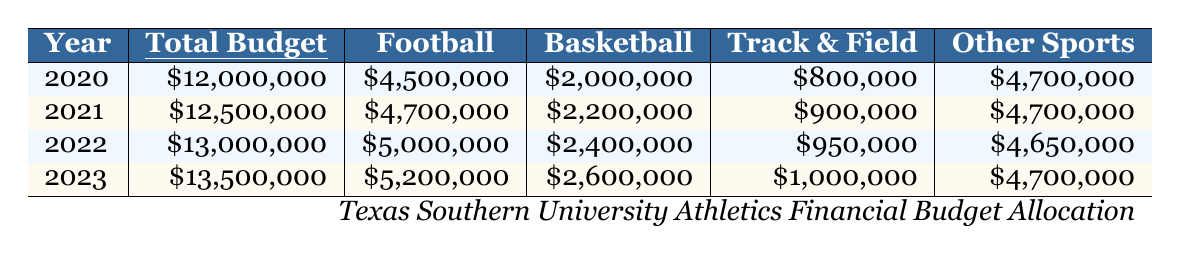What was the total budget for Texas Southern University Athletics in 2022? Referring to the 2022 row in the table, the total budget is listed as $13,000,000.
Answer: $13,000,000 How much did Texas Southern University allocate for football in 2023? The table shows that the football budget for 2023 is $5,200,000.
Answer: $5,200,000 Which year had the highest allocation for basketball? By comparing the basketball budgets in each year, 2023 has the highest allocation at $2,600,000.
Answer: 2023 What is the average budget for track and field over these four years? Adding the track and field budgets: ($800,000 + $900,000 + $950,000 + $1,000,000 = $3,650,000) and dividing by 4 gives an average of $912,500.
Answer: $912,500 Did the total budget increase every year from 2020 to 2023? The total budgets for each year are: $12,000,000 (2020), $12,500,000 (2021), $13,000,000 (2022), and $13,500,000 (2023), which shows an increase each year.
Answer: Yes What was the difference in football budget allocation between 2020 and 2023? The football budget for 2020 was $4,500,000 and for 2023 it was $5,200,000. The difference is $5,200,000 - $4,500,000 = $700,000.
Answer: $700,000 What percentage of the total budget in 2021 was allocated to other sports? In 2021, the total budget was $12,500,000, and the allocation for other sports was $4,700,000. The percentage is ($4,700,000 / $12,500,000) * 100 = 37.6%.
Answer: 37.6% Which sport had a consistent budget allocation over these years? The budget for other sports remained the same at $4,700,000 in both 2020 and 2021, and then adjusted slightly down to $4,650,000 in 2022 and went back to $4,700,000 in 2023, indicating inconsistency but relative stability.
Answer: Inconsistent, but relatively stable What was the total combined budget for football and basketball in 2022? The football budget in 2022 is $5,000,000 and the basketball budget is $2,400,000. Adding these together gives $5,000,000 + $2,400,000 = $7,400,000.
Answer: $7,400,000 If Texas Southern continued to increase their total budget at the same rate as from 2022 to 2023, what would the estimated total budget for 2024 be? The increase from 2022 to 2023 was $13,500,000 - $13,000,000 = $500,000. Adding this to the 2023 budget: $13,500,000 + $500,000 = $14,000,000.
Answer: $14,000,000 